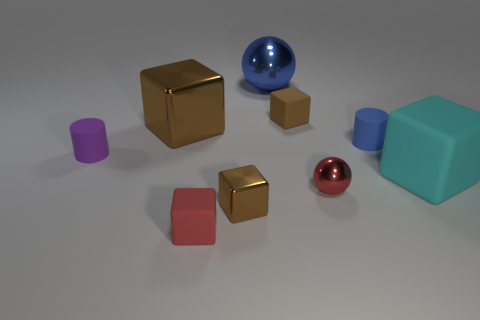Subtract all brown blocks. How many were subtracted if there are1brown blocks left? 2 Subtract all brown cylinders. How many brown cubes are left? 3 Subtract 1 blocks. How many blocks are left? 4 Subtract all cyan blocks. How many blocks are left? 4 Subtract all large brown blocks. How many blocks are left? 4 Subtract all green blocks. Subtract all brown cylinders. How many blocks are left? 5 Add 1 small purple objects. How many objects exist? 10 Subtract all cylinders. How many objects are left? 7 Add 4 large metallic spheres. How many large metallic spheres are left? 5 Add 4 small cylinders. How many small cylinders exist? 6 